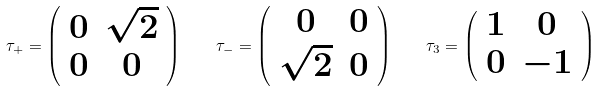Convert formula to latex. <formula><loc_0><loc_0><loc_500><loc_500>\tau _ { + } = \left ( \begin{array} { c c } 0 & \sqrt { 2 } \\ 0 & 0 \end{array} \right ) \quad \tau _ { - } = \left ( \begin{array} { c c } 0 & 0 \\ \sqrt { 2 } & 0 \end{array} \right ) \quad \tau _ { 3 } = \left ( \begin{array} { c c } 1 & 0 \\ 0 & - 1 \end{array} \right )</formula> 